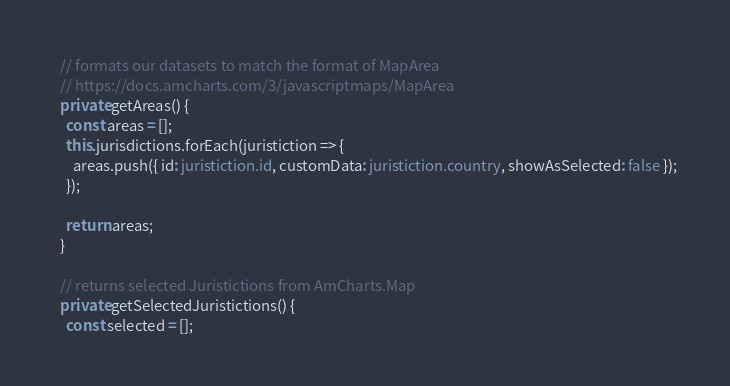Convert code to text. <code><loc_0><loc_0><loc_500><loc_500><_TypeScript_>  // formats our datasets to match the format of MapArea
  // https://docs.amcharts.com/3/javascriptmaps/MapArea
  private getAreas() {
    const areas = [];
    this.jurisdictions.forEach(juristiction => {
      areas.push({ id: juristiction.id, customData: juristiction.country, showAsSelected: false });
    });

    return areas;
  }

  // returns selected Juristictions from AmCharts.Map
  private getSelectedJuristictions() {
    const selected = [];</code> 